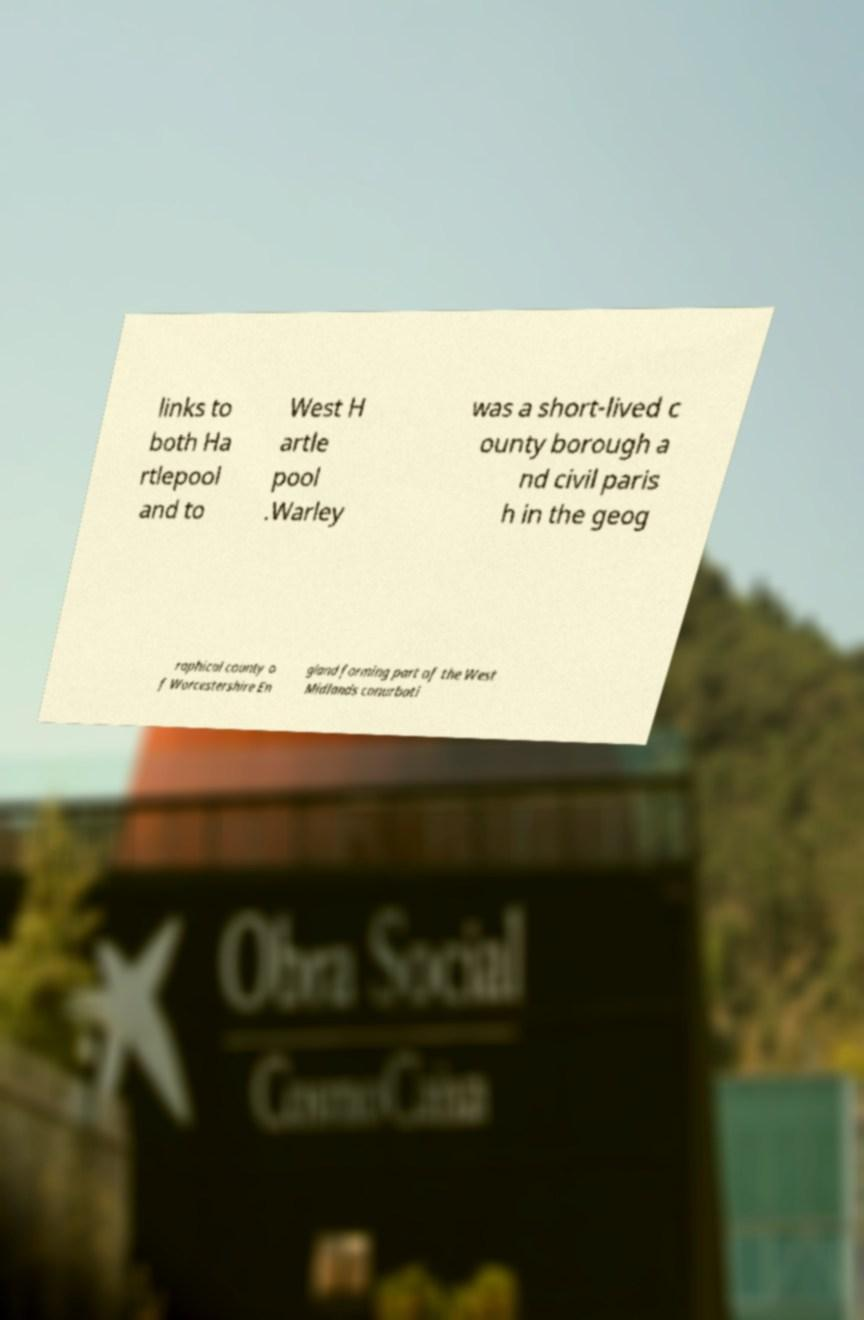Can you read and provide the text displayed in the image?This photo seems to have some interesting text. Can you extract and type it out for me? links to both Ha rtlepool and to West H artle pool .Warley was a short-lived c ounty borough a nd civil paris h in the geog raphical county o f Worcestershire En gland forming part of the West Midlands conurbati 